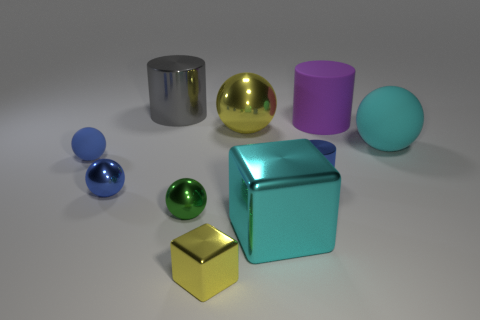Subtract all big gray metallic cylinders. How many cylinders are left? 2 Subtract all yellow cubes. How many cubes are left? 1 Subtract all purple cylinders. How many blue spheres are left? 2 Subtract all cylinders. How many objects are left? 7 Add 8 large blue matte cubes. How many large blue matte cubes exist? 8 Subtract 1 blue balls. How many objects are left? 9 Subtract 1 cubes. How many cubes are left? 1 Subtract all red blocks. Subtract all yellow balls. How many blocks are left? 2 Subtract all cubes. Subtract all yellow balls. How many objects are left? 7 Add 6 gray things. How many gray things are left? 7 